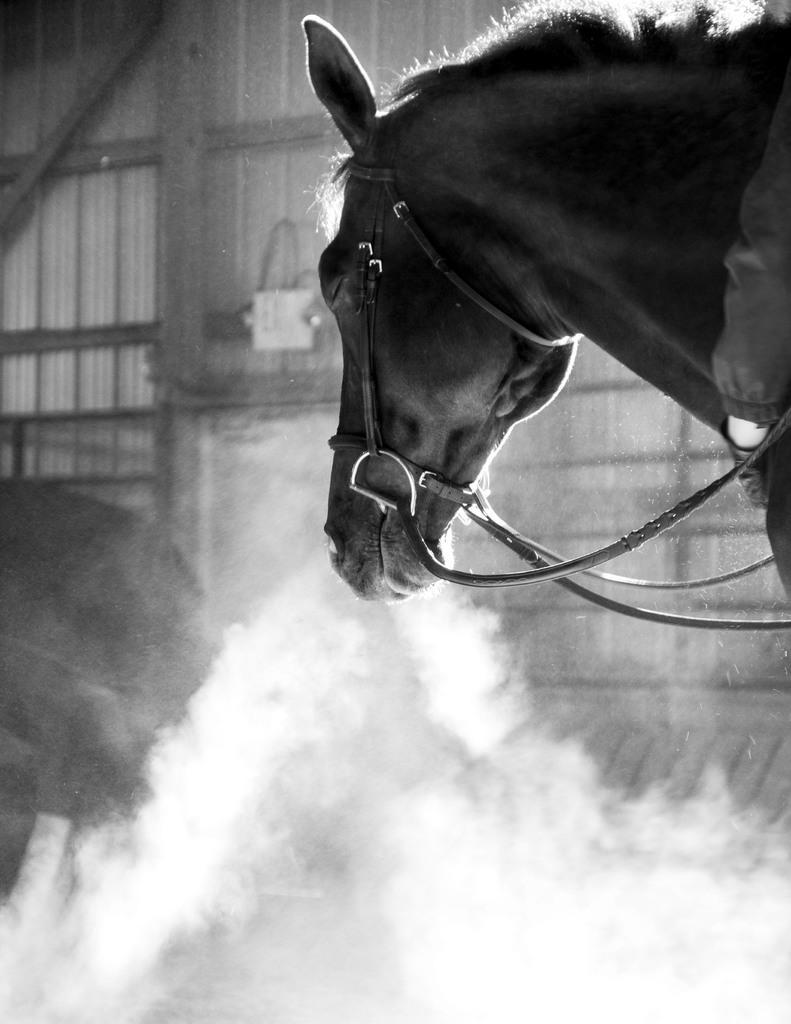Please provide a concise description of this image. There is a black and white image. There is a horse in the top right of the image. There is a smoke at the bottom of the image. 